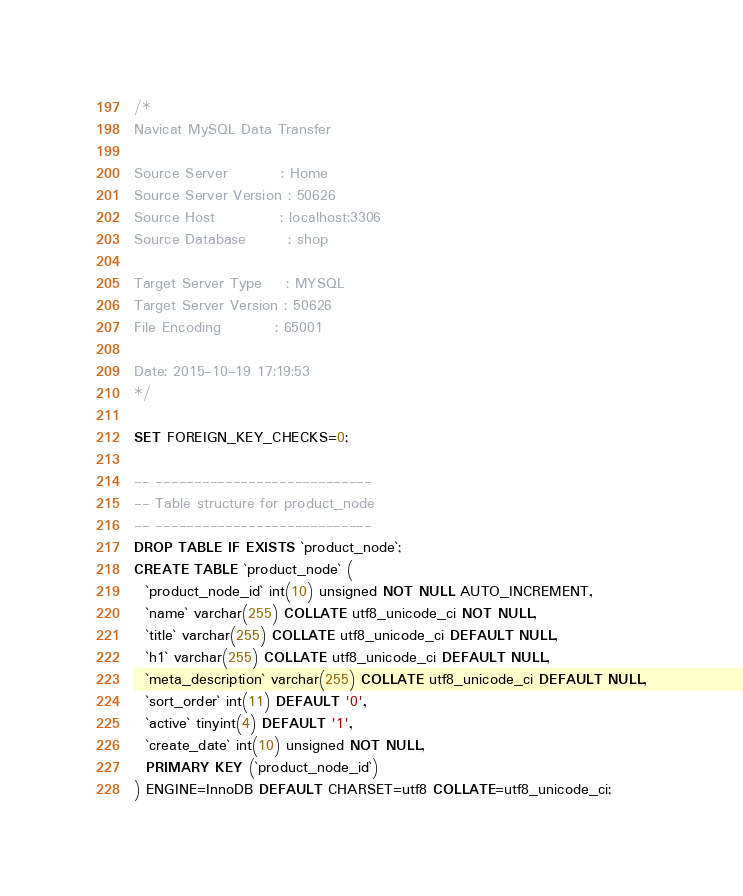<code> <loc_0><loc_0><loc_500><loc_500><_SQL_>/*
Navicat MySQL Data Transfer

Source Server         : Home
Source Server Version : 50626
Source Host           : localhost:3306
Source Database       : shop

Target Server Type    : MYSQL
Target Server Version : 50626
File Encoding         : 65001

Date: 2015-10-19 17:19:53
*/

SET FOREIGN_KEY_CHECKS=0;

-- ----------------------------
-- Table structure for product_node
-- ----------------------------
DROP TABLE IF EXISTS `product_node`;
CREATE TABLE `product_node` (
  `product_node_id` int(10) unsigned NOT NULL AUTO_INCREMENT,
  `name` varchar(255) COLLATE utf8_unicode_ci NOT NULL,
  `title` varchar(255) COLLATE utf8_unicode_ci DEFAULT NULL,
  `h1` varchar(255) COLLATE utf8_unicode_ci DEFAULT NULL,
  `meta_description` varchar(255) COLLATE utf8_unicode_ci DEFAULT NULL,
  `sort_order` int(11) DEFAULT '0',
  `active` tinyint(4) DEFAULT '1',
  `create_date` int(10) unsigned NOT NULL,
  PRIMARY KEY (`product_node_id`)
) ENGINE=InnoDB DEFAULT CHARSET=utf8 COLLATE=utf8_unicode_ci;
</code> 